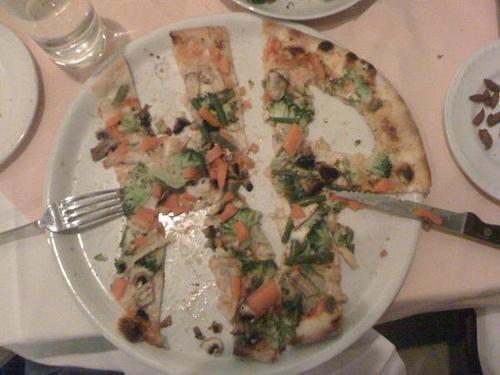How many people are eating food?
Give a very brief answer. 0. 